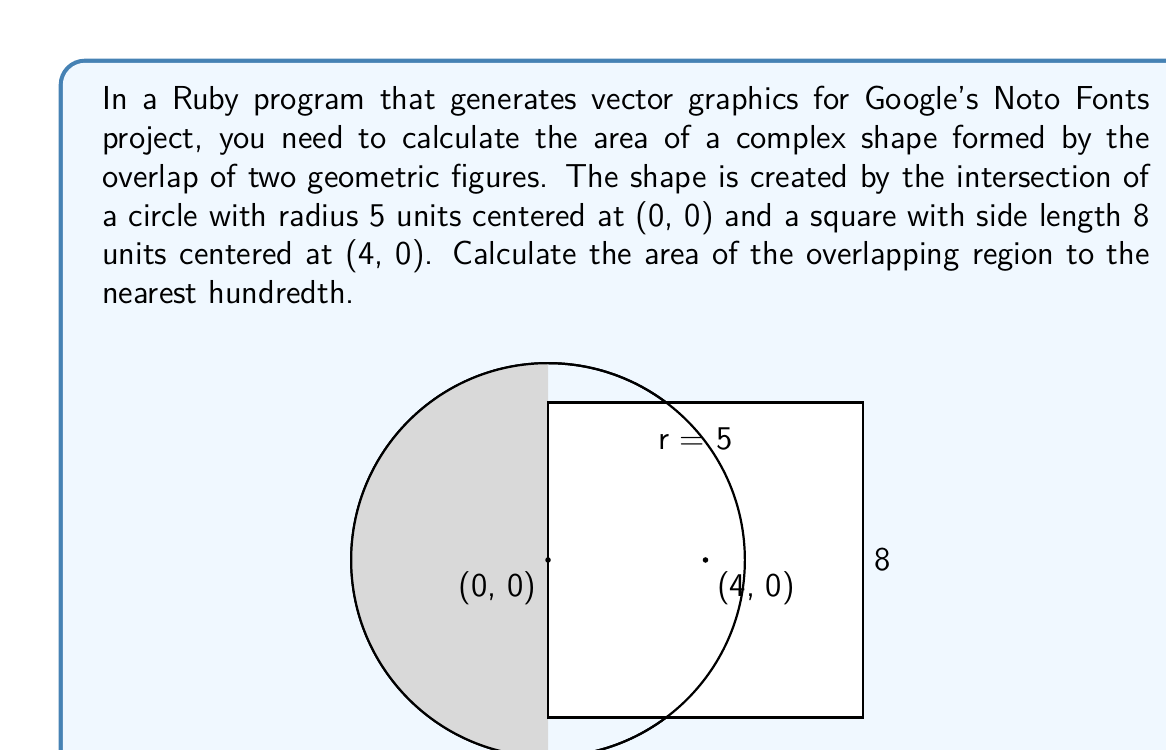Provide a solution to this math problem. To solve this problem, we'll follow these steps:

1) First, we need to find the points of intersection between the circle and the square. Due to symmetry, we only need to calculate one point.

2) The equation of the circle is $x^2 + y^2 = 25$, and the left side of the square is at $x = 0$.

3) Solving these equations simultaneously:
   $0^2 + y^2 = 25$
   $y = \pm 5$

   So the points of intersection are (0, 5) and (0, -5).

4) The overlapping region consists of a circular segment and a rectangle.

5) The area of the circular segment:
   $$A_{segment} = r^2 \arccos(\frac{r-h}{r}) - (r-h)\sqrt{2rh-h^2}$$
   where $r = 5$ and $h = 5$ (the height of the segment is the radius)
   
   $$A_{segment} = 25 \arccos(0) - 0 = 25 \cdot \frac{\pi}{2} = \frac{25\pi}{2}$$

6) The area of the rectangle:
   $$A_{rectangle} = 5 \cdot 4 = 20$$

7) The total area is the sum of these two:
   $$A_{total} = \frac{25\pi}{2} + 20 \approx 59.27$$

8) Rounding to the nearest hundredth gives 59.27 square units.
Answer: 59.27 square units 